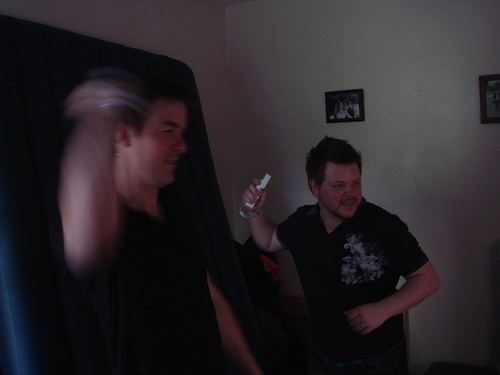<image>What are the blue figures on the man's shirt? I am not sure about the blue figures on the man's shirt. It could be sharks, dolphins, a logo, a dragon, or waves. What are the blue figures on the man's shirt? I don't know what the blue figures on the man's shirt are. It can be seen sharks, dolphins, logo, dragon, waves or something else. 